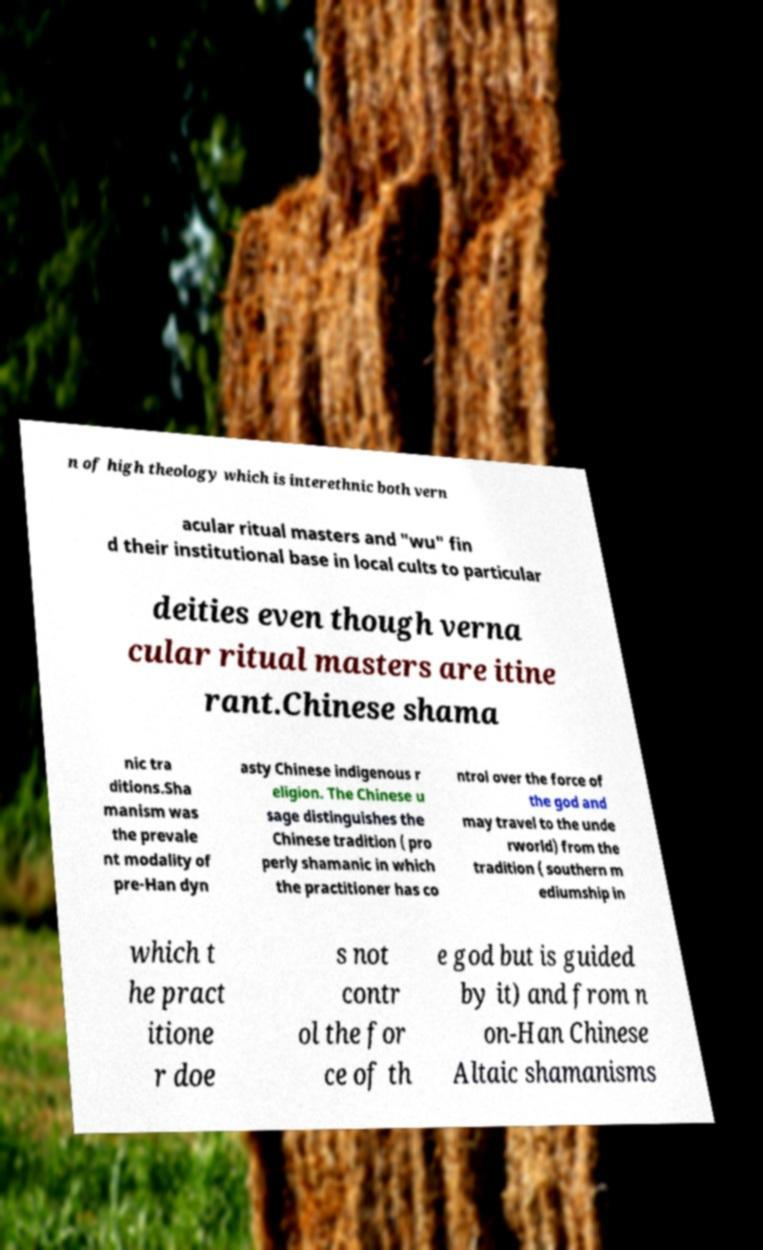Can you accurately transcribe the text from the provided image for me? n of high theology which is interethnic both vern acular ritual masters and "wu" fin d their institutional base in local cults to particular deities even though verna cular ritual masters are itine rant.Chinese shama nic tra ditions.Sha manism was the prevale nt modality of pre-Han dyn asty Chinese indigenous r eligion. The Chinese u sage distinguishes the Chinese tradition ( pro perly shamanic in which the practitioner has co ntrol over the force of the god and may travel to the unde rworld) from the tradition ( southern m ediumship in which t he pract itione r doe s not contr ol the for ce of th e god but is guided by it) and from n on-Han Chinese Altaic shamanisms 